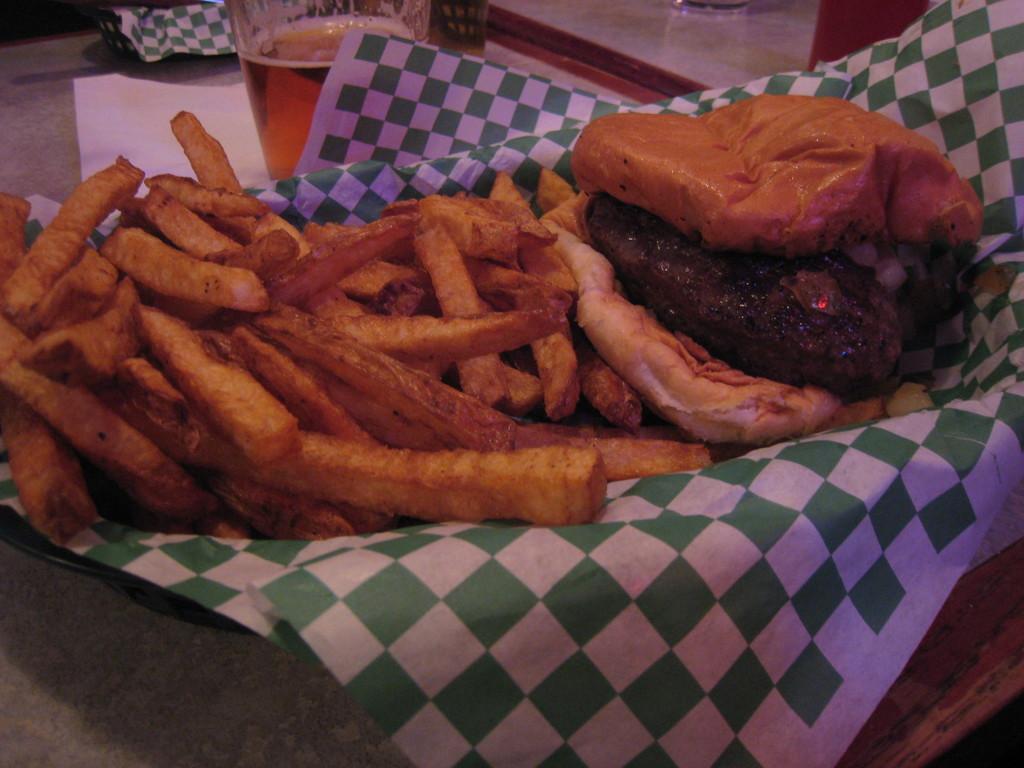Please provide a concise description of this image. In this picture we can see a plate with a paper and on the paper there are some food items and the plate is on an object. Behind the plate there is a glass with some liquid, paper and other things. 